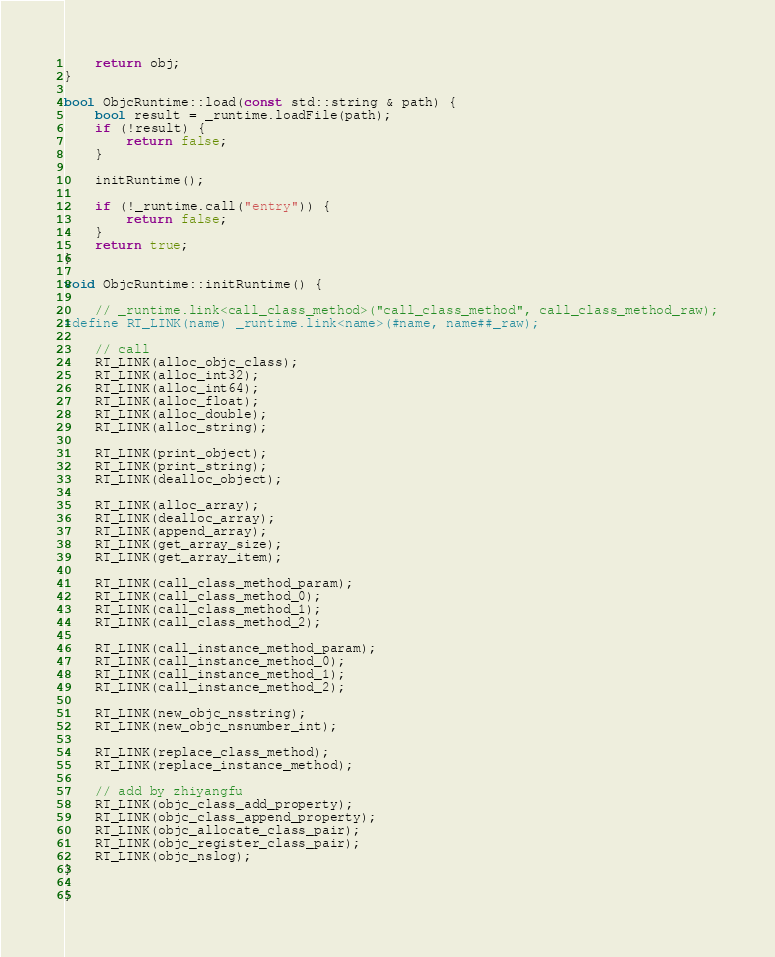<code> <loc_0><loc_0><loc_500><loc_500><_ObjectiveC_>    return obj;
}

bool ObjcRuntime::load(const std::string & path) {
    bool result = _runtime.loadFile(path);
    if (!result) {
        return false;
    }
    
    initRuntime();
    
    if (!_runtime.call("entry")) {
        return false;
    }
    return true;
}

void ObjcRuntime::initRuntime() {
    
    // _runtime.link<call_class_method>("call_class_method", call_class_method_raw);
#define RT_LINK(name) _runtime.link<name>(#name, name##_raw);
    
    // call
    RT_LINK(alloc_objc_class);
    RT_LINK(alloc_int32);
    RT_LINK(alloc_int64);
    RT_LINK(alloc_float);
    RT_LINK(alloc_double);
    RT_LINK(alloc_string);
    
    RT_LINK(print_object);
    RT_LINK(print_string);
    RT_LINK(dealloc_object);
    
    RT_LINK(alloc_array);
    RT_LINK(dealloc_array);
    RT_LINK(append_array);
    RT_LINK(get_array_size);
    RT_LINK(get_array_item);
    
    RT_LINK(call_class_method_param);
    RT_LINK(call_class_method_0);
    RT_LINK(call_class_method_1);
    RT_LINK(call_class_method_2);
    
    RT_LINK(call_instance_method_param);
    RT_LINK(call_instance_method_0);
    RT_LINK(call_instance_method_1);
    RT_LINK(call_instance_method_2);
    
    RT_LINK(new_objc_nsstring);
    RT_LINK(new_objc_nsnumber_int);
    
    RT_LINK(replace_class_method);
    RT_LINK(replace_instance_method);
    
    // add by zhiyangfu
    RT_LINK(objc_class_add_property);
    RT_LINK(objc_class_append_property);
    RT_LINK(objc_allocate_class_pair);
    RT_LINK(objc_register_class_pair);
    RT_LINK(objc_nslog);
}

}
</code> 